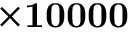Convert formula to latex. <formula><loc_0><loc_0><loc_500><loc_500>\times 1 0 0 0 0</formula> 